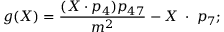<formula> <loc_0><loc_0><loc_500><loc_500>g ( X ) = \frac { ( X \cdot p _ { 4 } ) p _ { 4 7 } } { m ^ { 2 } } - X \, \cdot \, p _ { 7 } ;</formula> 